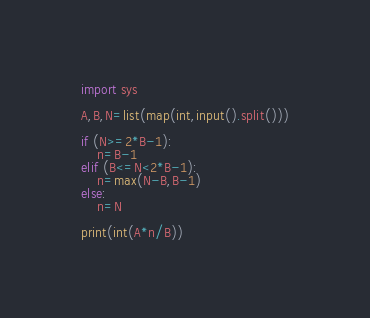Convert code to text. <code><loc_0><loc_0><loc_500><loc_500><_Python_>import sys

A,B,N=list(map(int,input().split()))

if (N>=2*B-1):
    n=B-1
elif (B<=N<2*B-1):
    n=max(N-B,B-1)
else:
    n=N

print(int(A*n/B))</code> 